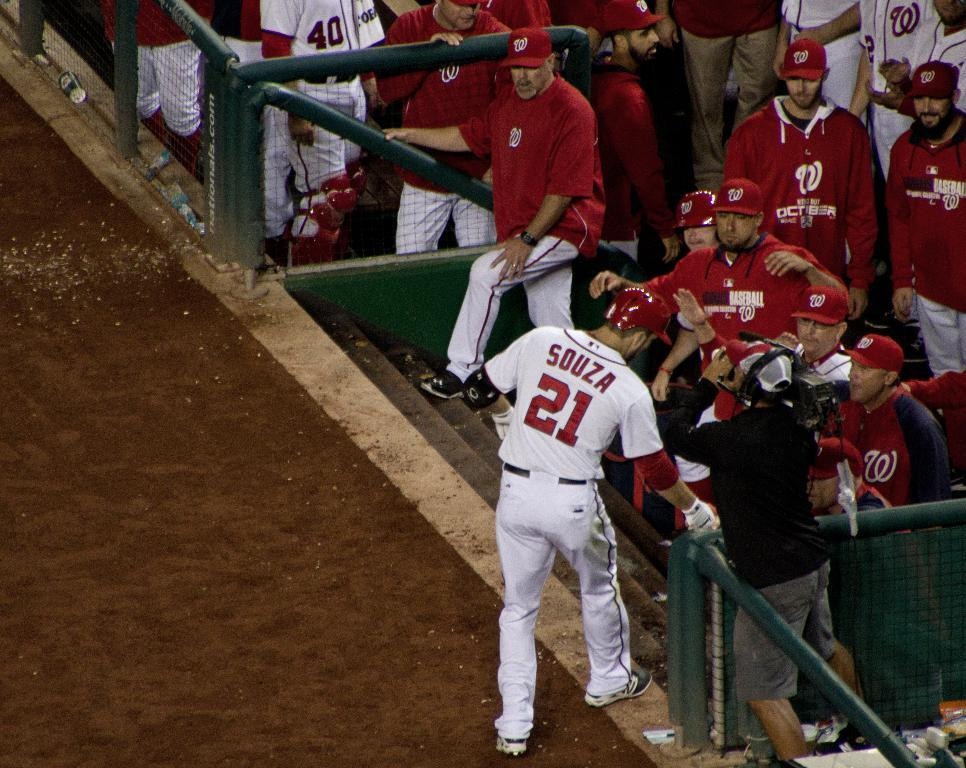<image>
Offer a succinct explanation of the picture presented. A baseball player named Souza approaches the dugout. 